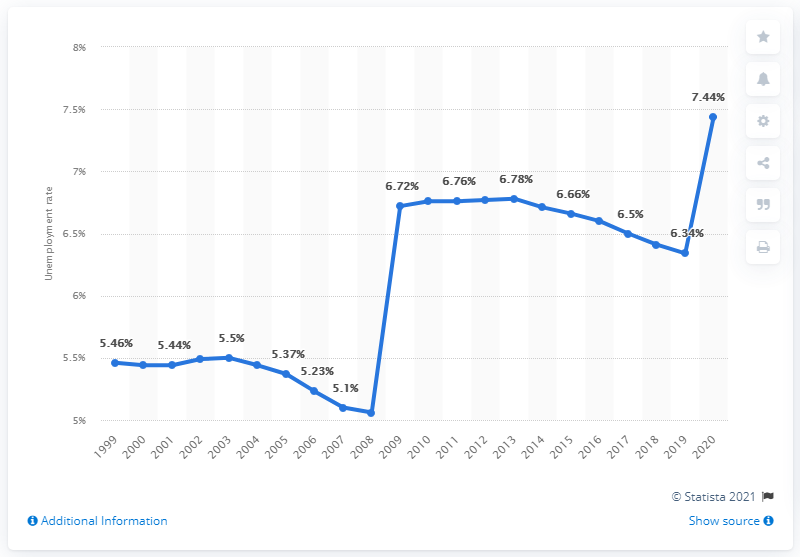Specify some key components in this picture. In 2020, the unemployment rate in Eritrea was 7.44 percent. 